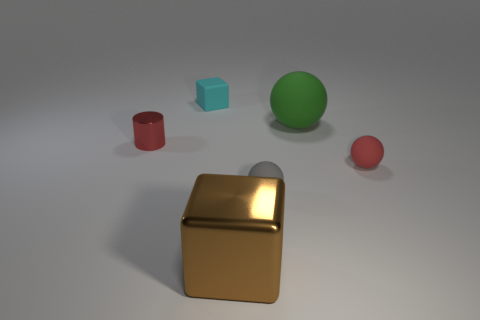There is a thing that is the same color as the tiny metallic cylinder; what is its material?
Your answer should be compact. Rubber. There is a brown metallic block; is its size the same as the sphere that is left of the large green sphere?
Your response must be concise. No. Do the thing that is to the left of the cyan thing and the brown shiny block have the same size?
Provide a short and direct response. No. What number of other things are the same material as the red cylinder?
Your answer should be compact. 1. Are there an equal number of large brown metallic blocks behind the green sphere and tiny blocks on the left side of the small cyan rubber cube?
Your response must be concise. Yes. There is a metallic thing behind the big shiny cube in front of the tiny rubber object behind the small shiny cylinder; what is its color?
Keep it short and to the point. Red. There is a metallic object left of the small cyan cube; what is its shape?
Make the answer very short. Cylinder. What shape is the small gray object that is made of the same material as the small cyan cube?
Ensure brevity in your answer.  Sphere. Is there anything else that is the same shape as the red metal object?
Offer a terse response. No. There is a large brown block; what number of big brown blocks are left of it?
Give a very brief answer. 0. 